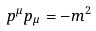Convert formula to latex. <formula><loc_0><loc_0><loc_500><loc_500>p ^ { \mu } p _ { \mu } = - m ^ { 2 }</formula> 